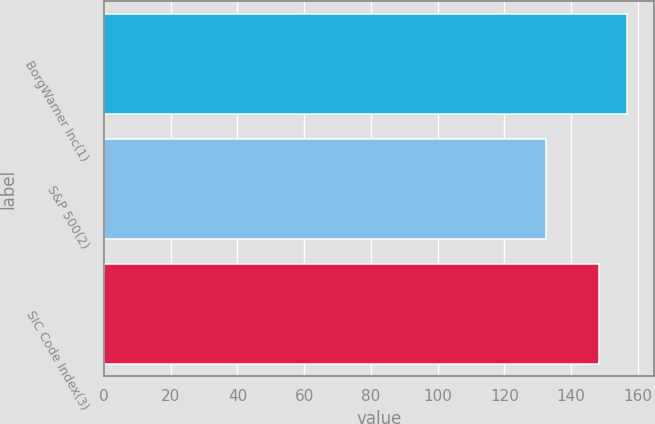Convert chart. <chart><loc_0><loc_0><loc_500><loc_500><bar_chart><fcel>BorgWarner Inc(1)<fcel>S&P 500(2)<fcel>SIC Code Index(3)<nl><fcel>156.91<fcel>132.39<fcel>148.42<nl></chart> 